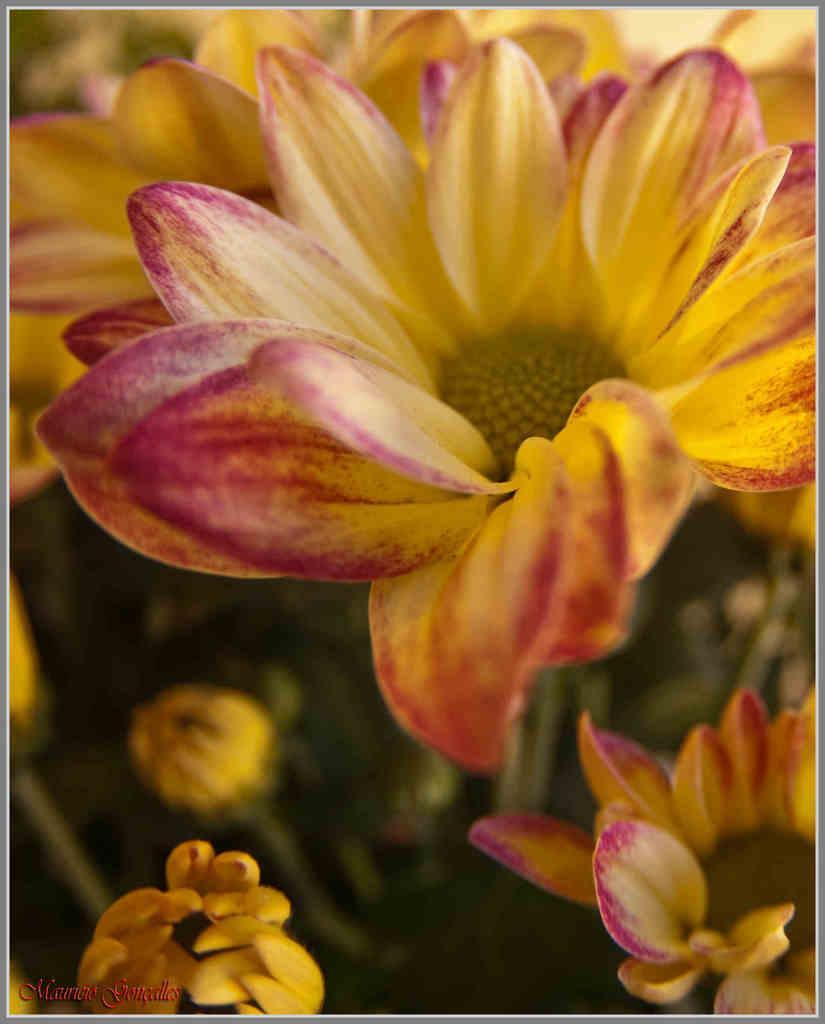How would you summarize this image in a sentence or two? In this picture we can see flowers in the front, there is a blurry background, at the left bottom we can see some text. 